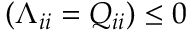<formula> <loc_0><loc_0><loc_500><loc_500>( \Lambda _ { i i } = Q _ { i i } ) \leq 0</formula> 